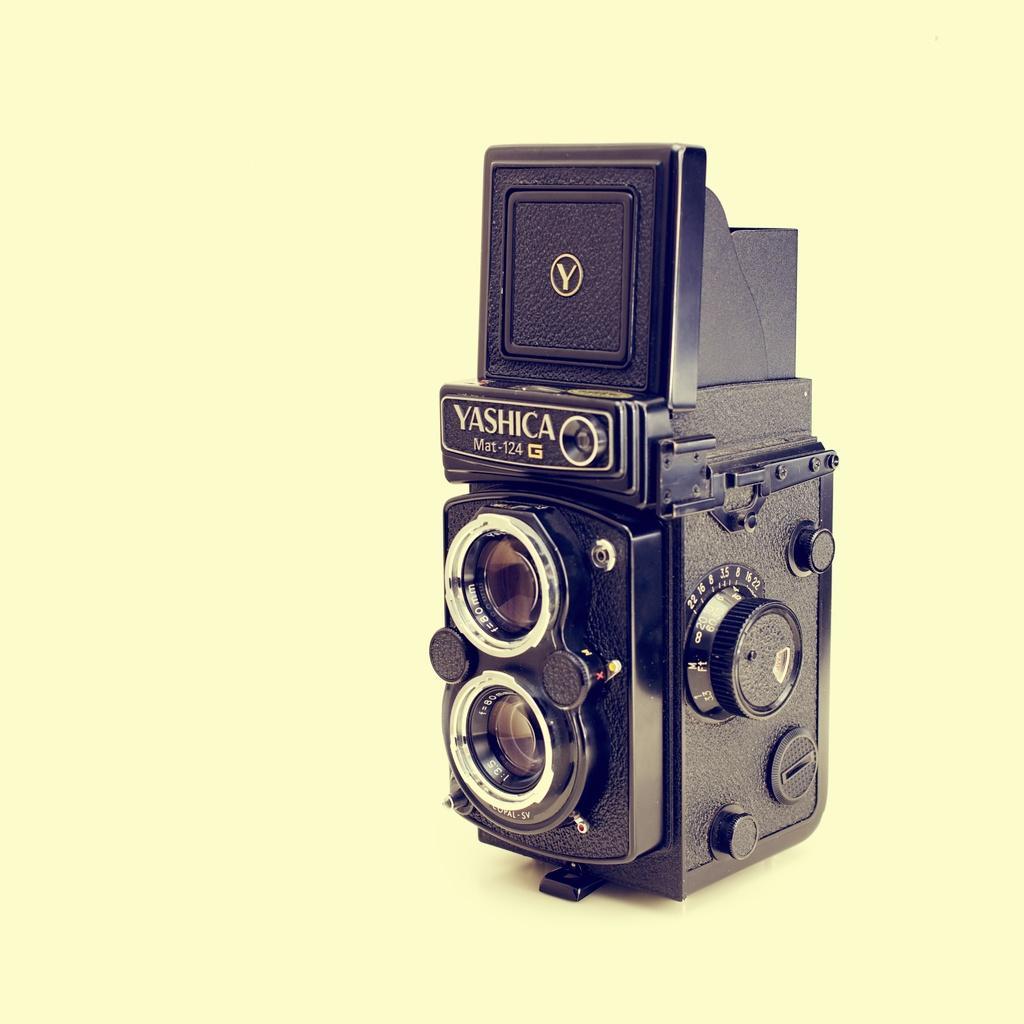Describe this image in one or two sentences. In the picture we can see a camera with two lenses and it is black in color. 